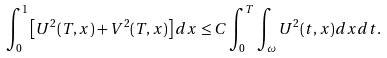<formula> <loc_0><loc_0><loc_500><loc_500>\int _ { 0 } ^ { 1 } \left [ U ^ { 2 } ( T , x ) + V ^ { 2 } ( T , x ) \right ] d x \leq C \int _ { 0 } ^ { T } \int _ { \omega } U ^ { 2 } ( t , x ) d x d t .</formula> 